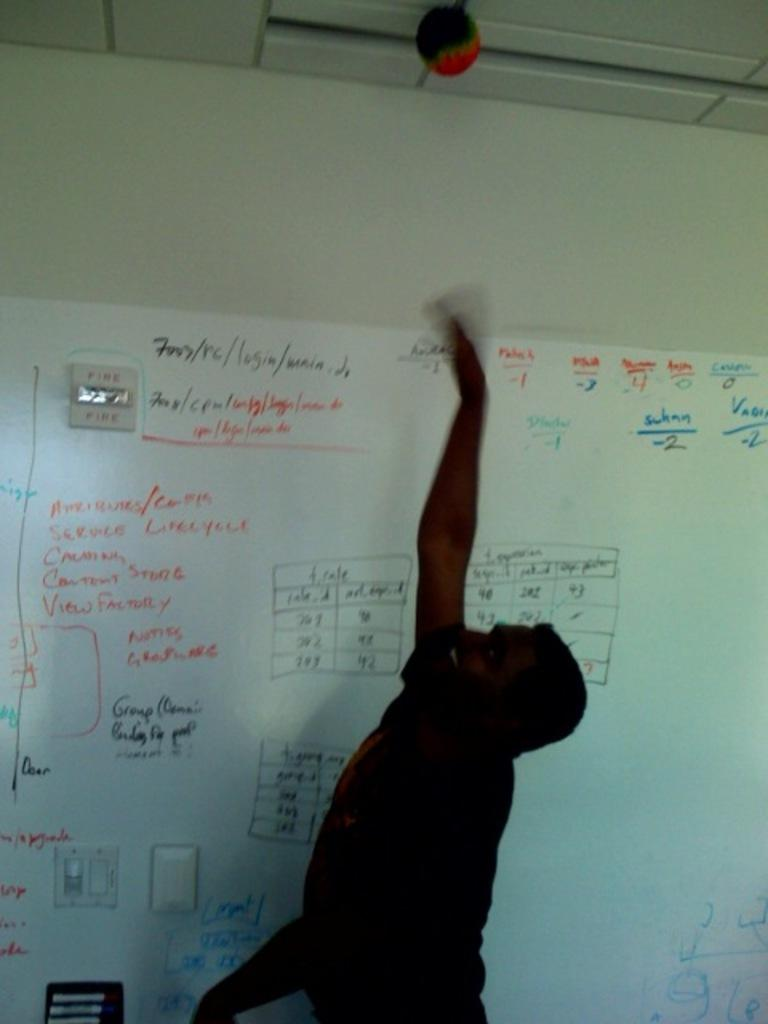Who is present in the image? There is a man in the image. What is the man's facial expression? The man is smiling. What can be seen on the board in the image? There is text on the board in the image. What other items are visible in the image? There are objects in the image. What is visible in the background of the image? There is a wall in the background of the image. What type of pot is being used to zip up the lumber in the image? There is no pot, zipper, or lumber present in the image. 